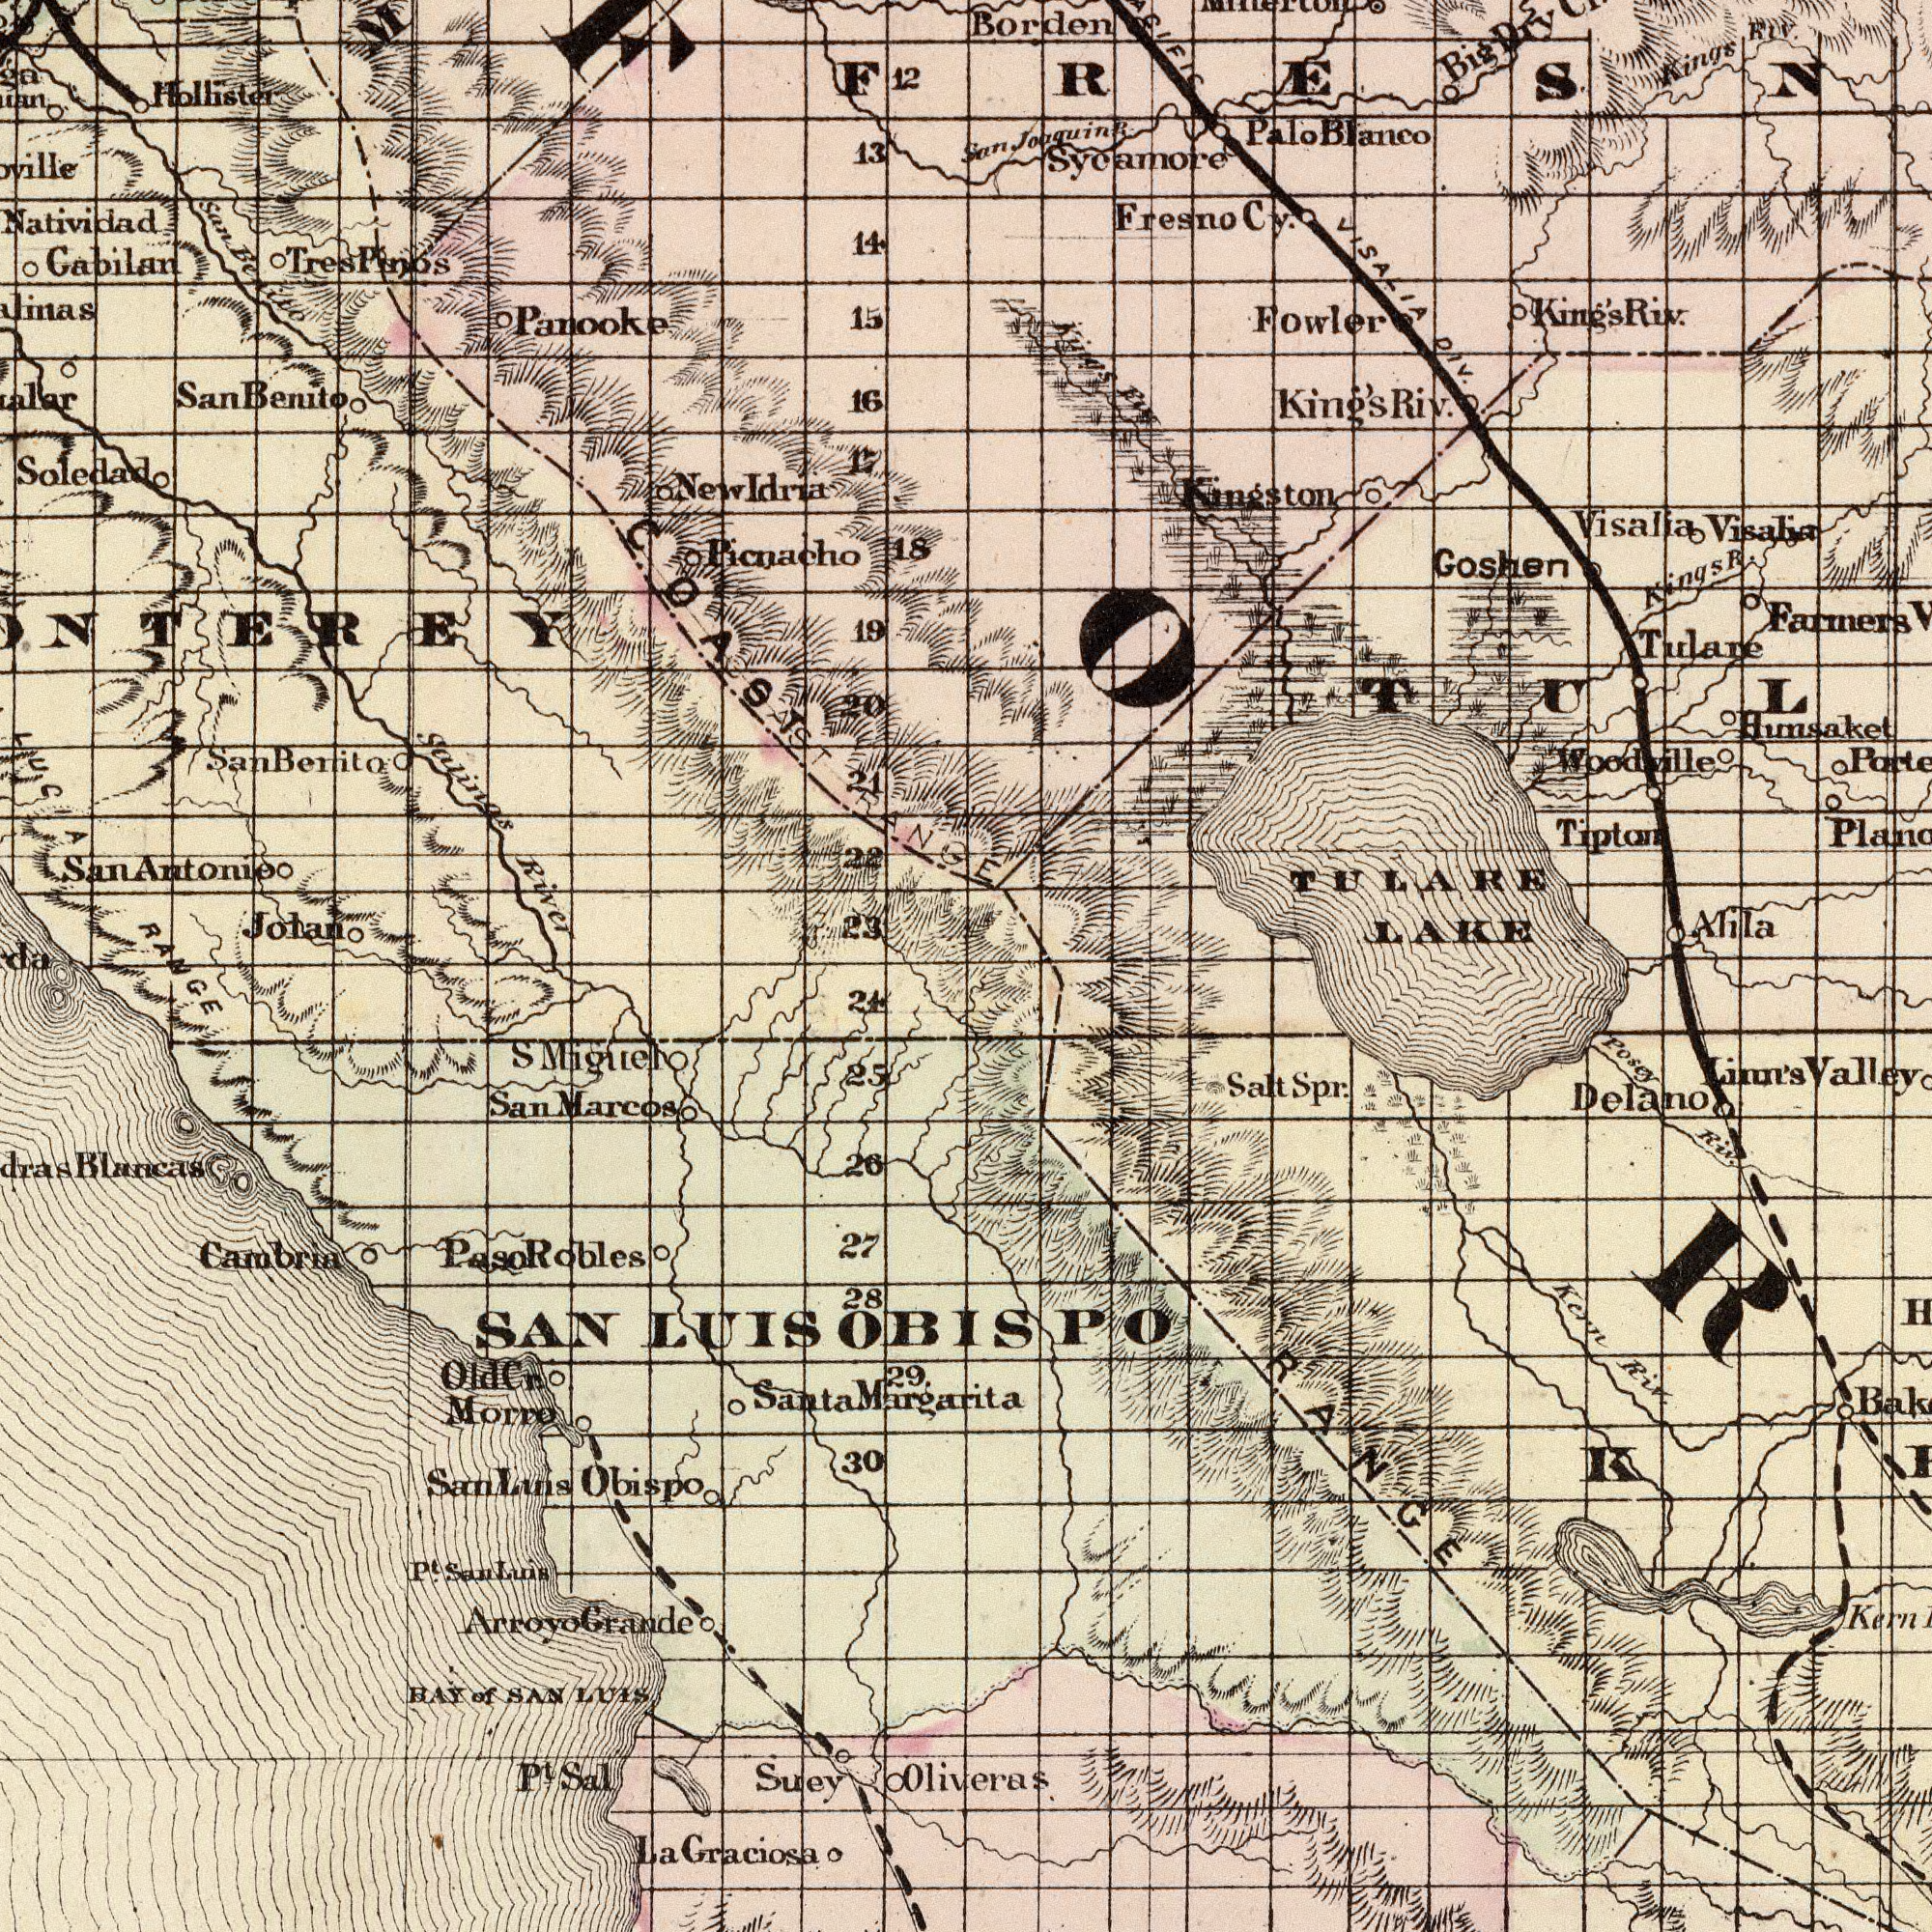What text can you see in the top-left section? River Panooke Picnacho Salinas 18 Jolan Hollister 23 13 15 22 Soledad 14 12 19 20 Benito Idria 17 San Gabilan Natividad Antonio 21 Benito New San LUCIA Tres San COAST RANGE 16 Pinos Benito COAST San What text can you see in the top-right section? LAKE Hunsaket Borden TULARE Tulane Riv. Visalia Tipton Farmers Woodville Goshen King's Alila Riv. Fresno Kingston Riv. Sycamore Kings Joaquing King's Blanco Cy. Big Kings DIV. Palo R. Fowler San VISALIA Dry Visalia R. Kings Riv. What text can you see in the bottom-left section? RANGE Graciosa SAN Cambria Obispo Blancas Suey Marcos 30 San 27 29. Morro Migllel La 26 LUIS BAY SAN 28 24 P<sup>t</sup>. 25 P<sup>t</sup>. Grande San Margarita Arroyo LUIS S Sal Santa Luis of Cr. Paso Robles Luis San Old What text is visible in the lower-right corner? Oliveras Kern Delano RANGE Kern Posey Valley Linn's Spr. Riv. Riv. Salt OBISPO 